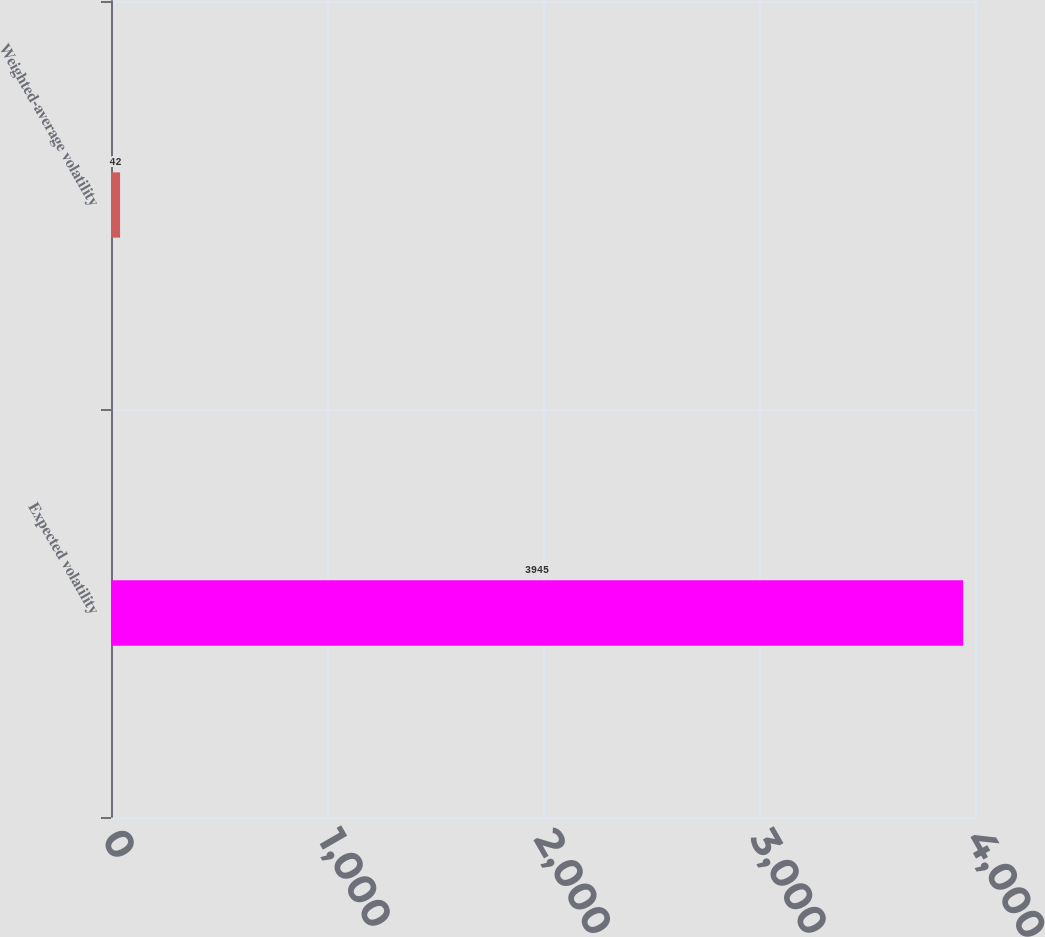Convert chart to OTSL. <chart><loc_0><loc_0><loc_500><loc_500><bar_chart><fcel>Expected volatility<fcel>Weighted-average volatility<nl><fcel>3945<fcel>42<nl></chart> 